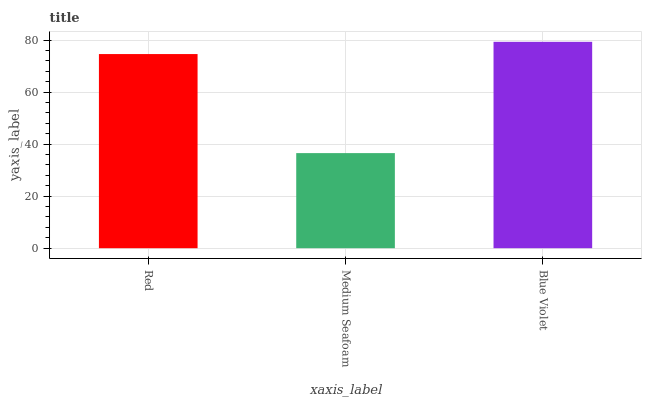Is Medium Seafoam the minimum?
Answer yes or no. Yes. Is Blue Violet the maximum?
Answer yes or no. Yes. Is Blue Violet the minimum?
Answer yes or no. No. Is Medium Seafoam the maximum?
Answer yes or no. No. Is Blue Violet greater than Medium Seafoam?
Answer yes or no. Yes. Is Medium Seafoam less than Blue Violet?
Answer yes or no. Yes. Is Medium Seafoam greater than Blue Violet?
Answer yes or no. No. Is Blue Violet less than Medium Seafoam?
Answer yes or no. No. Is Red the high median?
Answer yes or no. Yes. Is Red the low median?
Answer yes or no. Yes. Is Medium Seafoam the high median?
Answer yes or no. No. Is Blue Violet the low median?
Answer yes or no. No. 